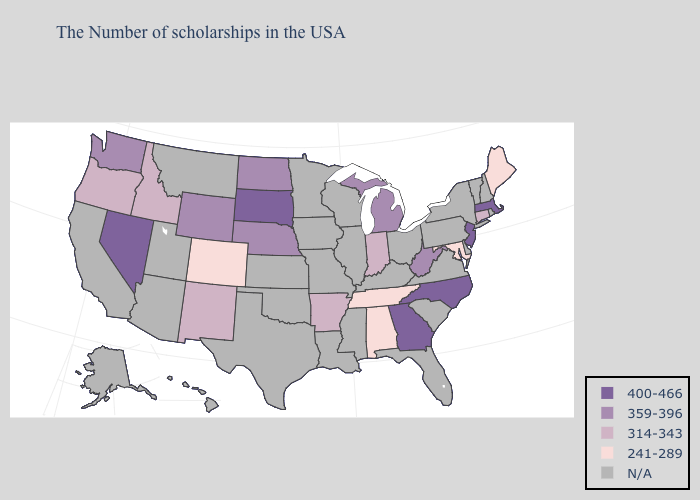Does New Jersey have the highest value in the USA?
Be succinct. Yes. Name the states that have a value in the range N/A?
Write a very short answer. Rhode Island, New Hampshire, Vermont, New York, Delaware, Pennsylvania, Virginia, South Carolina, Ohio, Florida, Kentucky, Wisconsin, Illinois, Mississippi, Louisiana, Missouri, Minnesota, Iowa, Kansas, Oklahoma, Texas, Utah, Montana, Arizona, California, Alaska, Hawaii. Name the states that have a value in the range 359-396?
Keep it brief. West Virginia, Michigan, Nebraska, North Dakota, Wyoming, Washington. Among the states that border Oregon , which have the lowest value?
Concise answer only. Idaho. What is the value of Indiana?
Write a very short answer. 314-343. Name the states that have a value in the range 241-289?
Short answer required. Maine, Maryland, Alabama, Tennessee, Colorado. What is the lowest value in the MidWest?
Short answer required. 314-343. Name the states that have a value in the range 400-466?
Give a very brief answer. Massachusetts, New Jersey, North Carolina, Georgia, South Dakota, Nevada. What is the value of Montana?
Give a very brief answer. N/A. Does Maine have the highest value in the Northeast?
Quick response, please. No. Which states have the highest value in the USA?
Keep it brief. Massachusetts, New Jersey, North Carolina, Georgia, South Dakota, Nevada. Name the states that have a value in the range 359-396?
Answer briefly. West Virginia, Michigan, Nebraska, North Dakota, Wyoming, Washington. What is the value of New York?
Quick response, please. N/A. 